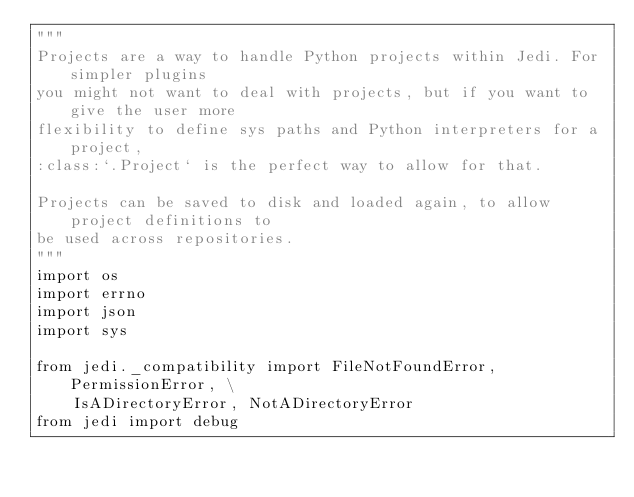<code> <loc_0><loc_0><loc_500><loc_500><_Python_>"""
Projects are a way to handle Python projects within Jedi. For simpler plugins
you might not want to deal with projects, but if you want to give the user more
flexibility to define sys paths and Python interpreters for a project,
:class:`.Project` is the perfect way to allow for that.

Projects can be saved to disk and loaded again, to allow project definitions to
be used across repositories.
"""
import os
import errno
import json
import sys

from jedi._compatibility import FileNotFoundError, PermissionError, \
    IsADirectoryError, NotADirectoryError
from jedi import debug</code> 